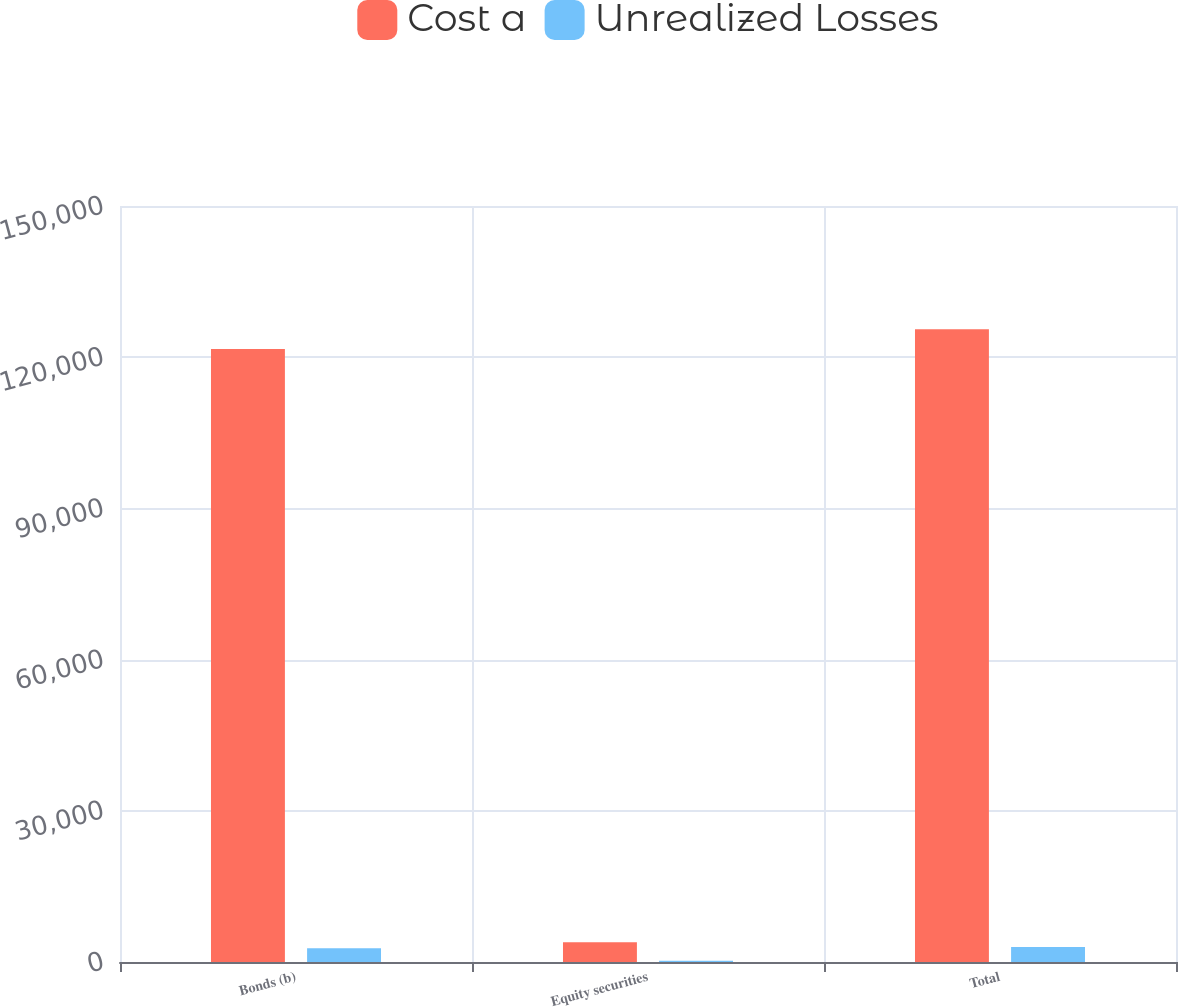<chart> <loc_0><loc_0><loc_500><loc_500><stacked_bar_chart><ecel><fcel>Bonds (b)<fcel>Equity securities<fcel>Total<nl><fcel>Cost a<fcel>121631<fcel>3894<fcel>125525<nl><fcel>Unrealized Losses<fcel>2715<fcel>246<fcel>2961<nl></chart> 